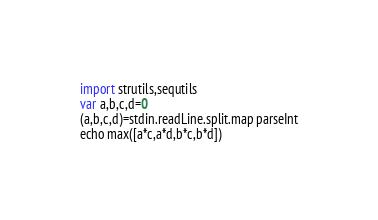Convert code to text. <code><loc_0><loc_0><loc_500><loc_500><_Nim_>import strutils,sequtils
var a,b,c,d=0
(a,b,c,d)=stdin.readLine.split.map parseInt
echo max([a*c,a*d,b*c,b*d])</code> 